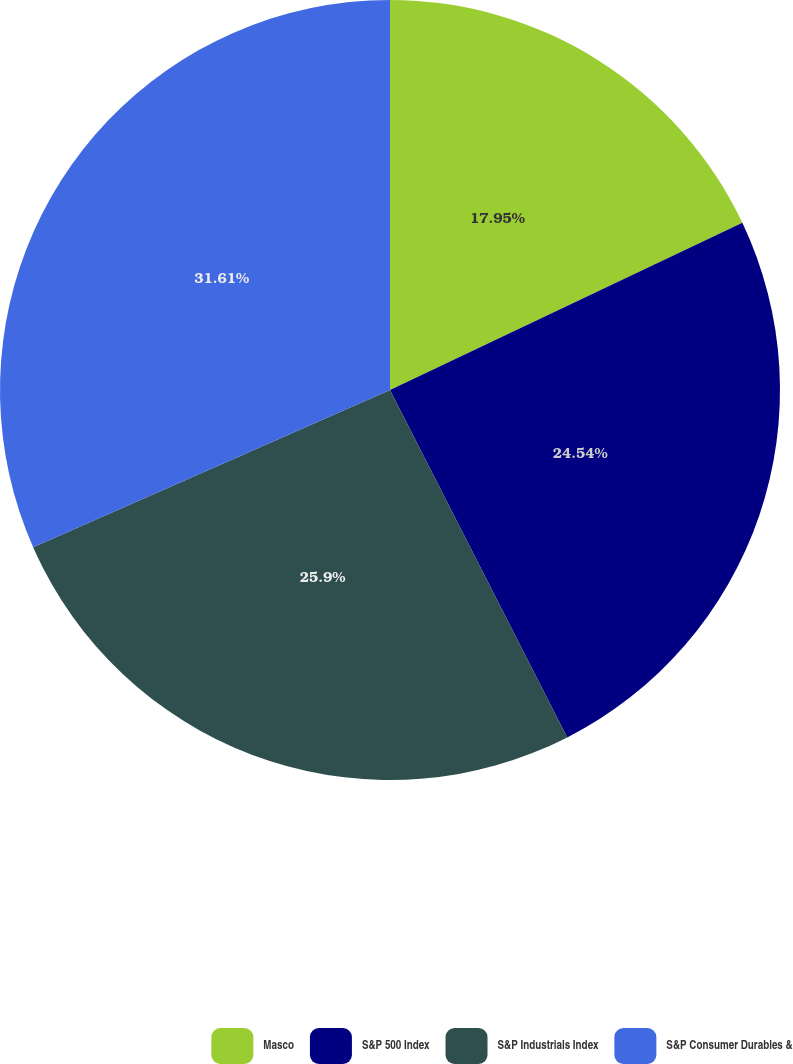Convert chart to OTSL. <chart><loc_0><loc_0><loc_500><loc_500><pie_chart><fcel>Masco<fcel>S&P 500 Index<fcel>S&P Industrials Index<fcel>S&P Consumer Durables &<nl><fcel>17.95%<fcel>24.54%<fcel>25.9%<fcel>31.61%<nl></chart> 